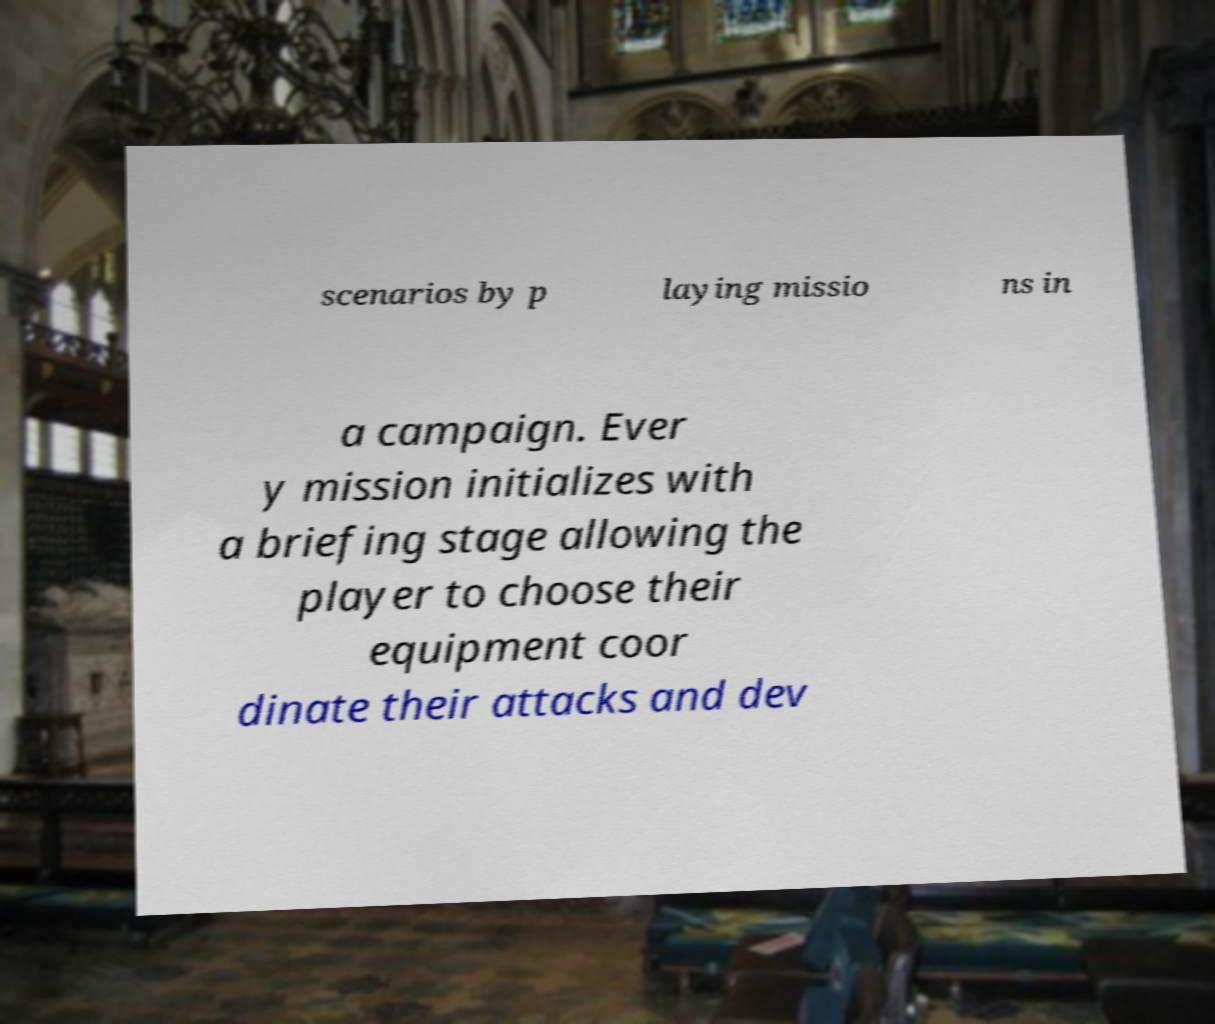Please read and relay the text visible in this image. What does it say? scenarios by p laying missio ns in a campaign. Ever y mission initializes with a briefing stage allowing the player to choose their equipment coor dinate their attacks and dev 